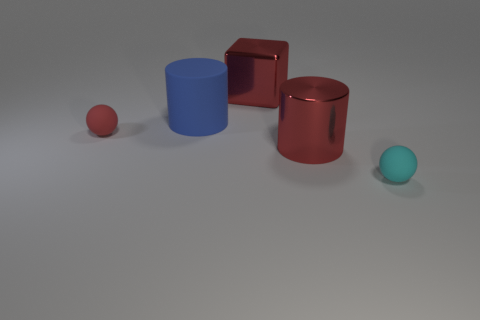Add 5 large blue matte things. How many objects exist? 10 Subtract all balls. How many objects are left? 3 Add 4 red balls. How many red balls exist? 5 Subtract 0 gray blocks. How many objects are left? 5 Subtract all big purple spheres. Subtract all cyan balls. How many objects are left? 4 Add 5 red shiny cylinders. How many red shiny cylinders are left? 6 